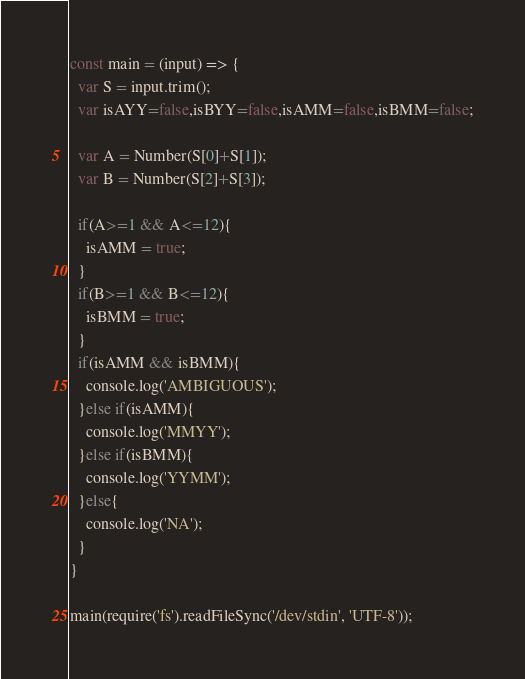<code> <loc_0><loc_0><loc_500><loc_500><_JavaScript_>const main = (input) => {
  var S = input.trim();
  var isAYY=false,isBYY=false,isAMM=false,isBMM=false;

  var A = Number(S[0]+S[1]);
  var B = Number(S[2]+S[3]);

  if(A>=1 && A<=12){
    isAMM = true;
  }
  if(B>=1 && B<=12){
    isBMM = true;
  }
  if(isAMM && isBMM){
    console.log('AMBIGUOUS');
  }else if(isAMM){
    console.log('MMYY');
  }else if(isBMM){
    console.log('YYMM');
  }else{
    console.log('NA');
  }
}

main(require('fs').readFileSync('/dev/stdin', 'UTF-8'));
</code> 